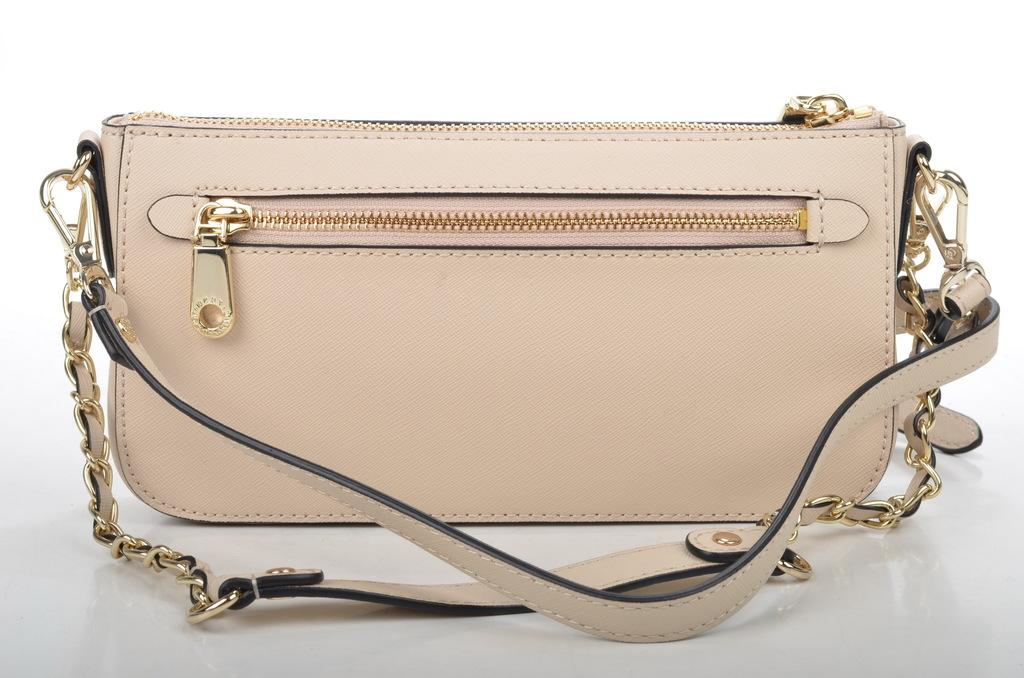What object is present in the image that can be used for carrying items? There is a bag in the image that can be used for carrying items. How can the contents of the bag be secured? The bag has a zip that can be used to secure the contents. What additional feature is present on the bag? The bag has a chain. What scientific experiment is being conducted with the bag in the image? There is no scientific experiment being conducted with the bag in the image. How can the contents of the bag be copied? The contents of the bag cannot be copied, as the bag is an object and not a source of information. 